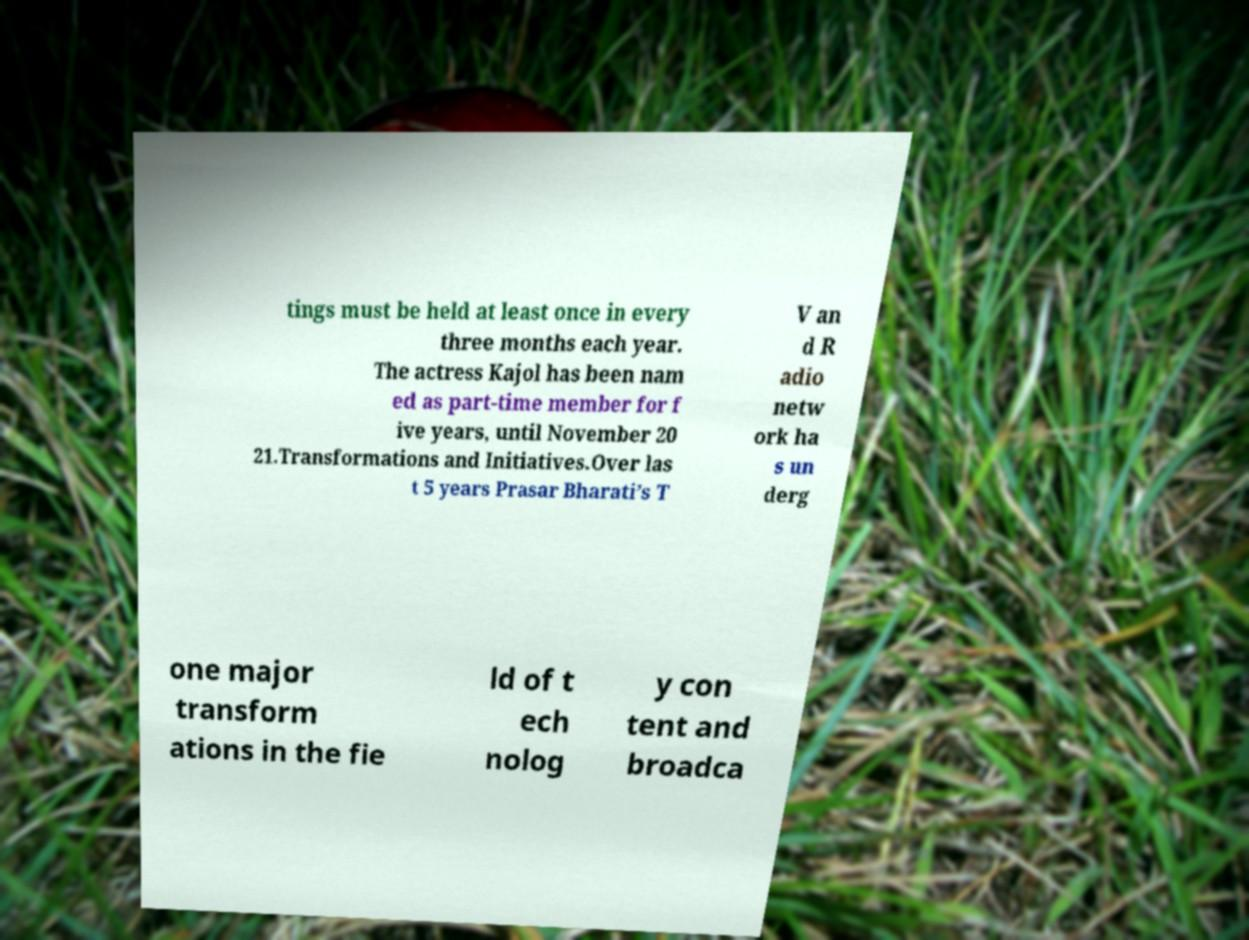Can you accurately transcribe the text from the provided image for me? tings must be held at least once in every three months each year. The actress Kajol has been nam ed as part-time member for f ive years, until November 20 21.Transformations and Initiatives.Over las t 5 years Prasar Bharati’s T V an d R adio netw ork ha s un derg one major transform ations in the fie ld of t ech nolog y con tent and broadca 